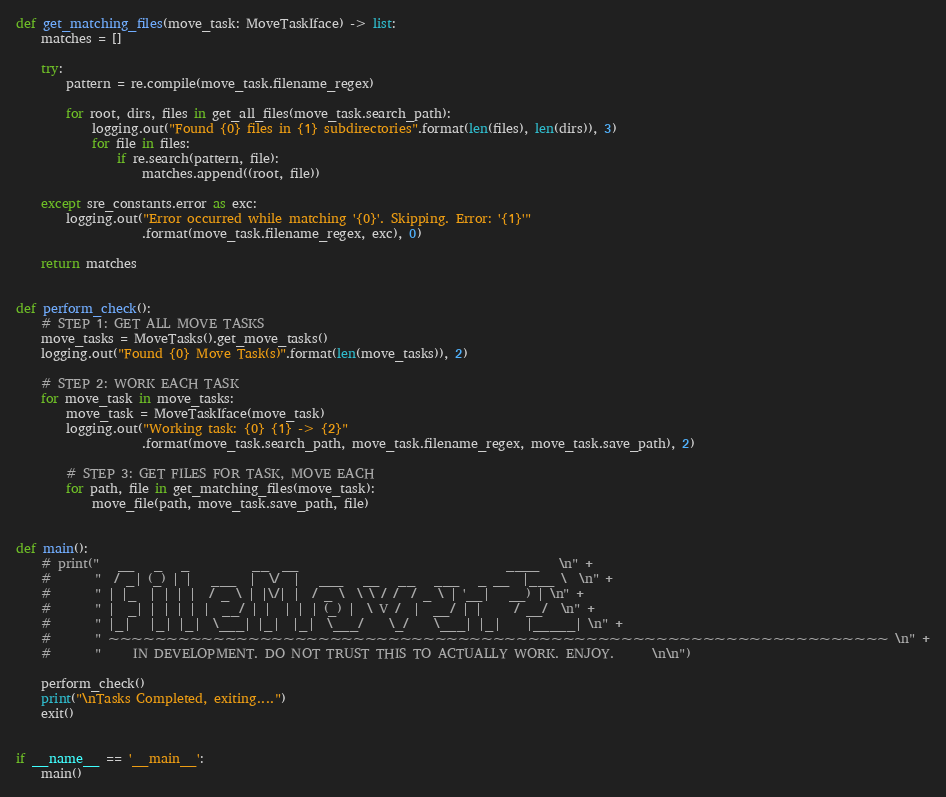Convert code to text. <code><loc_0><loc_0><loc_500><loc_500><_Python_>

def get_matching_files(move_task: MoveTaskIface) -> list:
    matches = []

    try:
        pattern = re.compile(move_task.filename_regex)

        for root, dirs, files in get_all_files(move_task.search_path):
            logging.out("Found {0} files in {1} subdirectories".format(len(files), len(dirs)), 3)
            for file in files:
                if re.search(pattern, file):
                    matches.append((root, file))

    except sre_constants.error as exc:
        logging.out("Error occurred while matching '{0}'. Skipping. Error: '{1}'"
                    .format(move_task.filename_regex, exc), 0)

    return matches


def perform_check():
    # STEP 1: GET ALL MOVE TASKS
    move_tasks = MoveTasks().get_move_tasks()
    logging.out("Found {0} Move Task(s)".format(len(move_tasks)), 2)

    # STEP 2: WORK EACH TASK
    for move_task in move_tasks:
        move_task = MoveTaskIface(move_task)
        logging.out("Working task: {0} {1} -> {2}"
                    .format(move_task.search_path, move_task.filename_regex, move_task.save_path), 2)

        # STEP 3: GET FILES FOR TASK, MOVE EACH
        for path, file in get_matching_files(move_task):
            move_file(path, move_task.save_path, file)


def main():
    # print("   __   _   _          __  __                                 ____   \n" +
    #       "  / _| (_) | |   ___  |  \/  |   ___   __   __   ___   _ __  |___ \  \n" +
    #       " | |_  | | | |  / _ \ | |\/| |  / _ \  \ \ / /  / _ \ | '__|   __) | \n" +
    #       " |  _| | | | | |  __/ | |  | | | (_) |  \ V /  |  __/ | |     / __/  \n" +
    #       " |_|   |_| |_|  \___| |_|  |_|  \___/    \_/    \___| |_|    |_____| \n" +
    #       " ~~~~~~~~~~~~~~~~~~~~~~~~~~~~~~~~~~~~~~~~~~~~~~~~~~~~~~~~~~~~~~~~~~~ \n" +
    #       "     IN DEVELOPMENT. DO NOT TRUST THIS TO ACTUALLY WORK. ENJOY.      \n\n")

    perform_check()
    print("\nTasks Completed, exiting....")
    exit()


if __name__ == '__main__':
    main()
</code> 